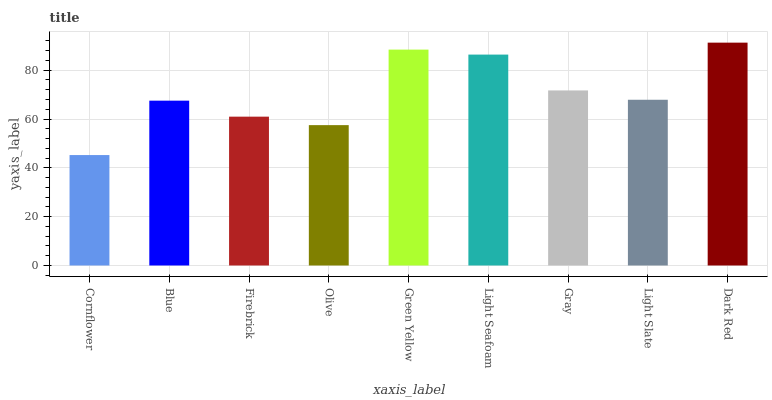Is Blue the minimum?
Answer yes or no. No. Is Blue the maximum?
Answer yes or no. No. Is Blue greater than Cornflower?
Answer yes or no. Yes. Is Cornflower less than Blue?
Answer yes or no. Yes. Is Cornflower greater than Blue?
Answer yes or no. No. Is Blue less than Cornflower?
Answer yes or no. No. Is Light Slate the high median?
Answer yes or no. Yes. Is Light Slate the low median?
Answer yes or no. Yes. Is Green Yellow the high median?
Answer yes or no. No. Is Firebrick the low median?
Answer yes or no. No. 